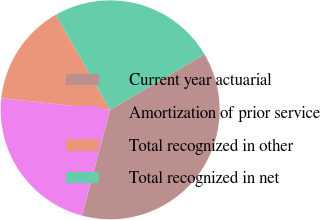Convert chart to OTSL. <chart><loc_0><loc_0><loc_500><loc_500><pie_chart><fcel>Current year actuarial<fcel>Amortization of prior service<fcel>Total recognized in other<fcel>Total recognized in net<nl><fcel>37.59%<fcel>22.56%<fcel>15.04%<fcel>24.81%<nl></chart> 